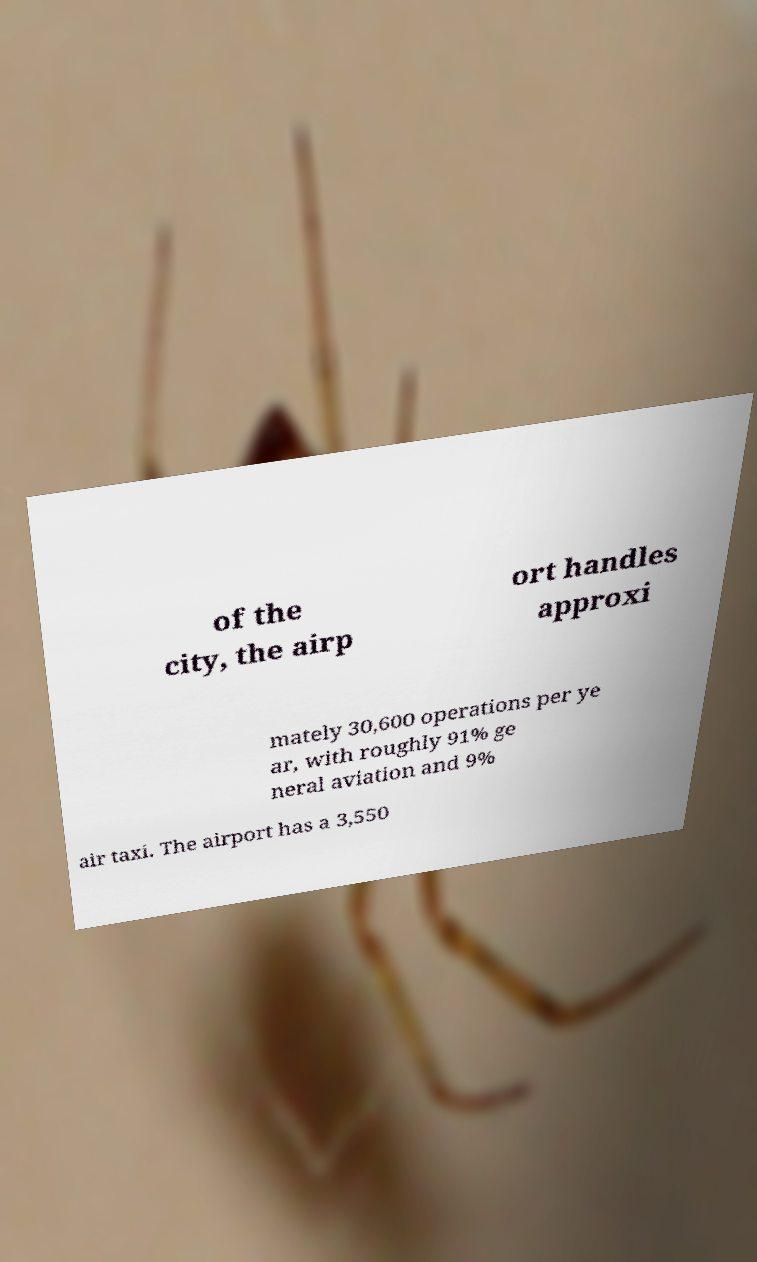I need the written content from this picture converted into text. Can you do that? of the city, the airp ort handles approxi mately 30,600 operations per ye ar, with roughly 91% ge neral aviation and 9% air taxi. The airport has a 3,550 